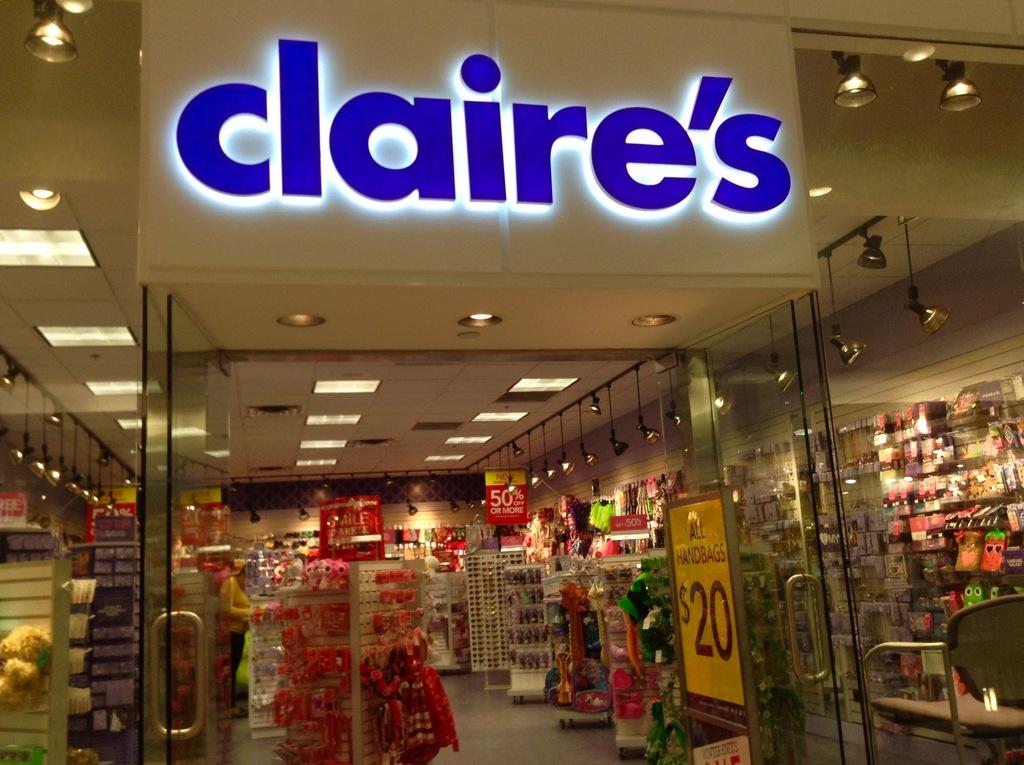What is the name of the jewelry store?
Give a very brief answer. Claire's. How much are all handbags?
Keep it short and to the point. $20. 